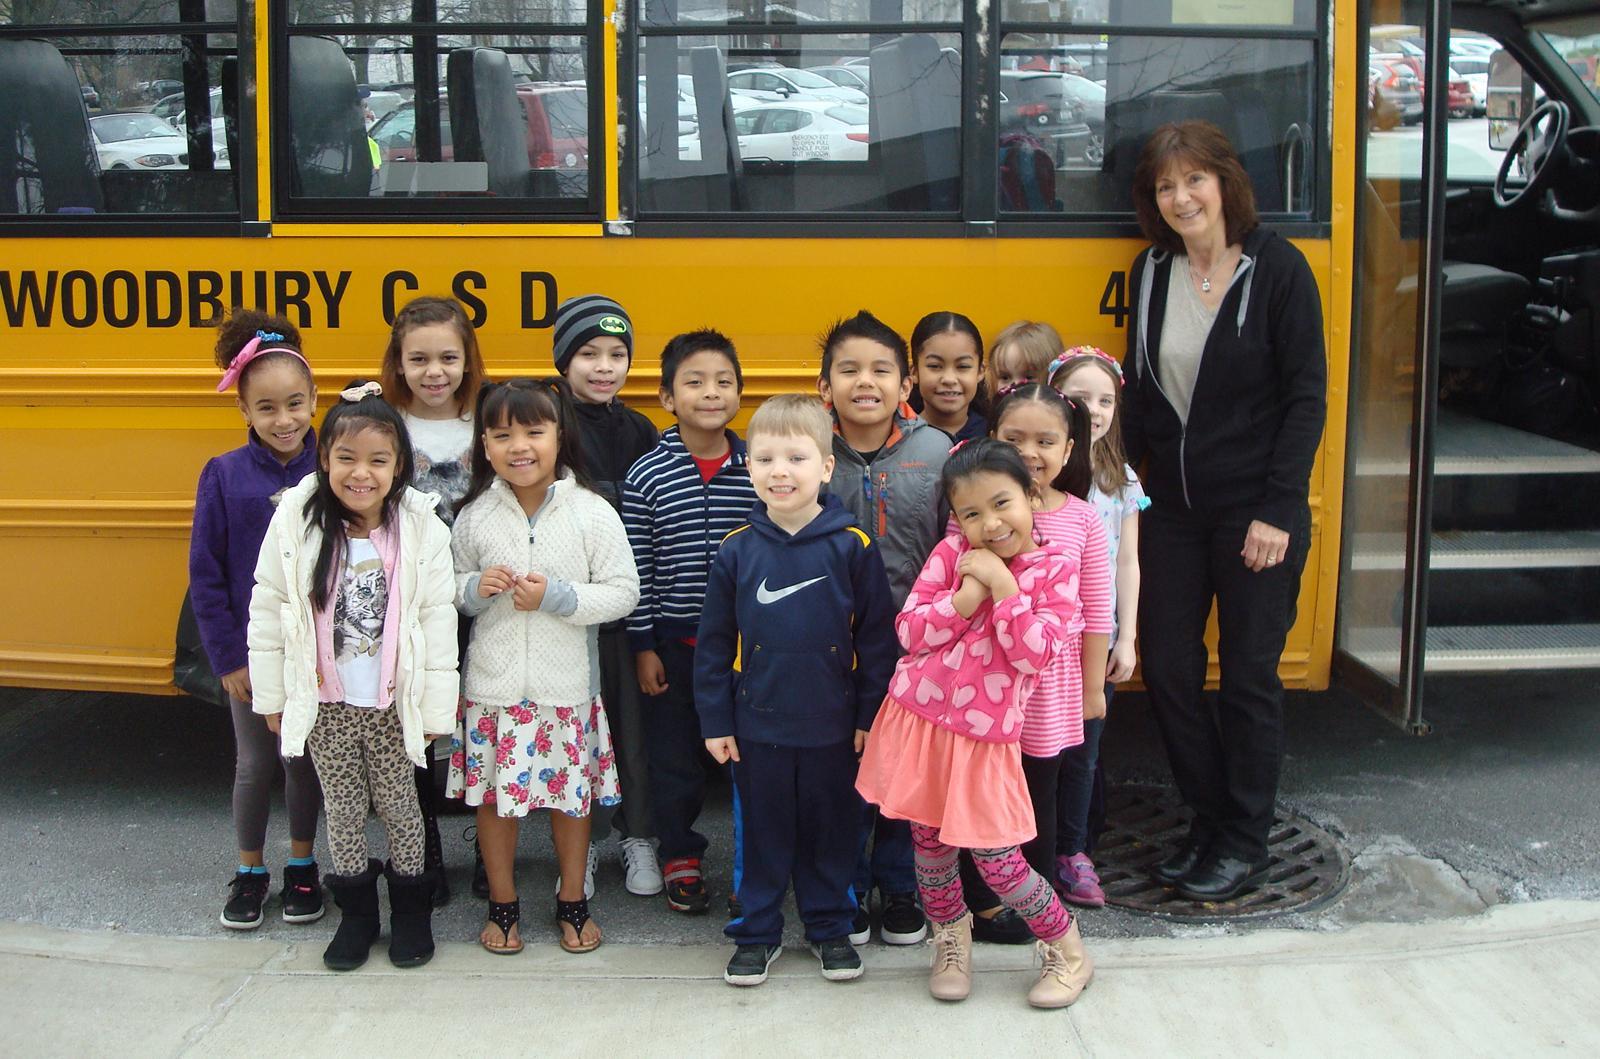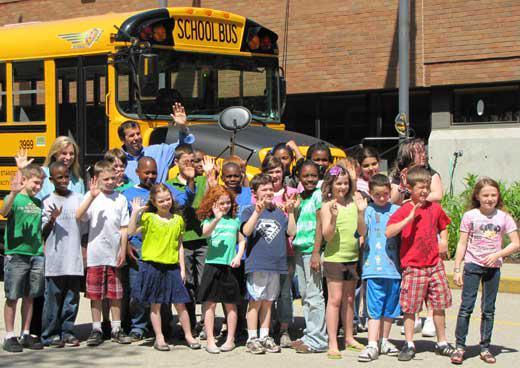The first image is the image on the left, the second image is the image on the right. For the images shown, is this caption "Each image shows children facing the camera and standing side-by-side in at least one horizontal line in front of the entry-door side of the bus." true? Answer yes or no. Yes. 